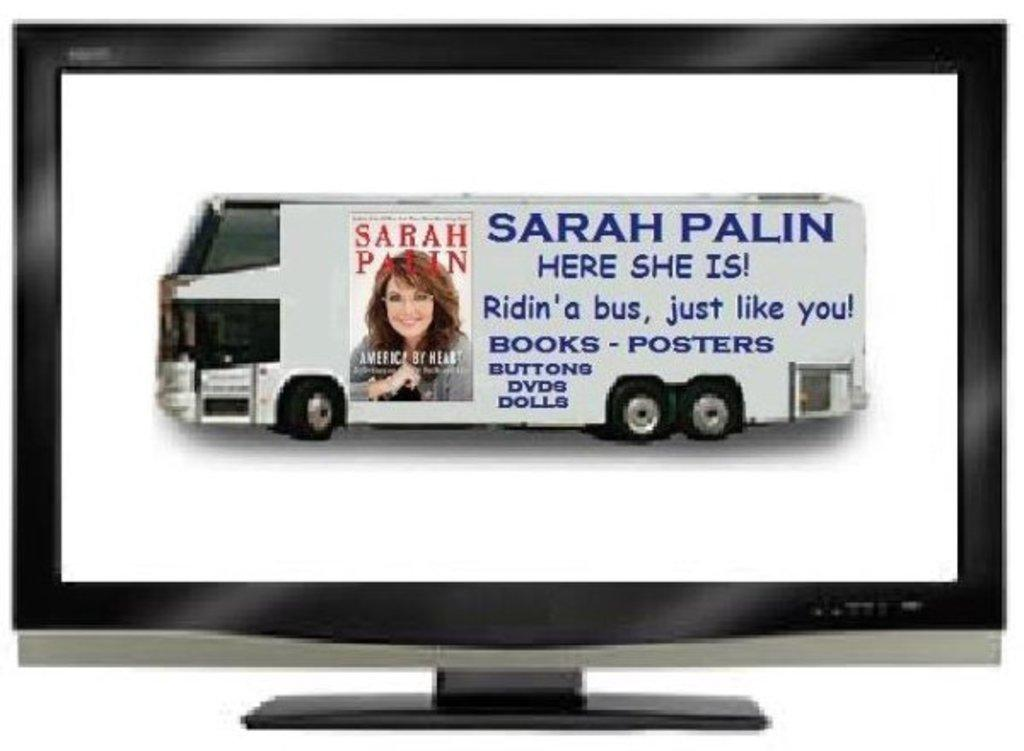<image>
Present a compact description of the photo's key features. A picture of a bus with a Sarah Palin advertisement on it features a picture of her book cover. 